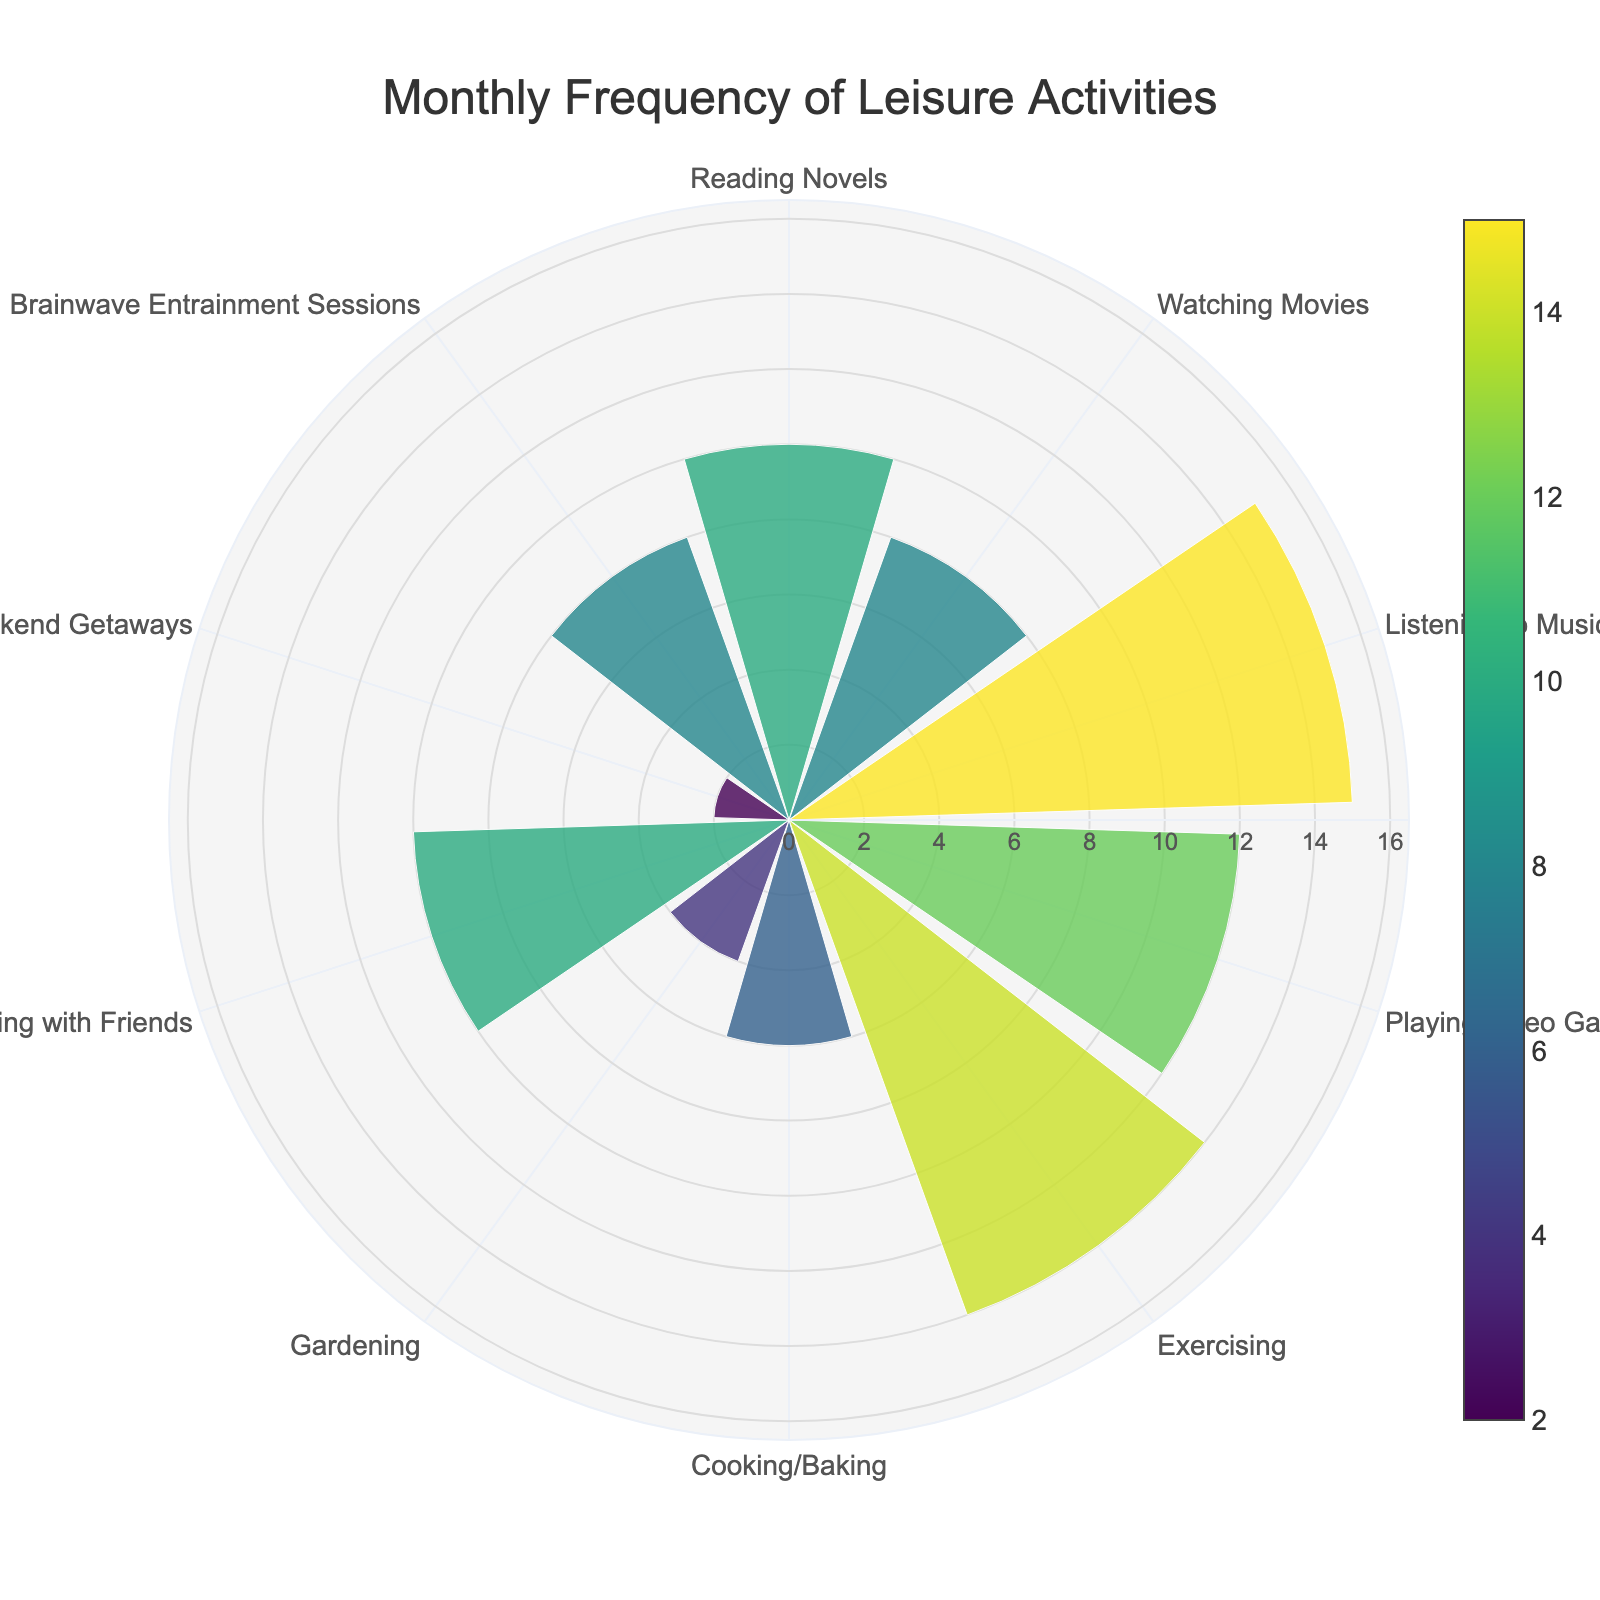What is the title of the chart? The title of the chart is usually displayed prominently at the top. By looking at the top center area of the figure, we can read the title "Monthly Frequency of Leisure Activities".
Answer: Monthly Frequency of Leisure Activities Which leisure activity has the highest frequency? To identify the activity with the highest frequency, look at the radial bars and see which one extends the furthest from the center. Listening to Music has the highest extension.
Answer: Listening to Music How many times per month do you have Brainwave Entrainment Sessions? By finding the label "Brainwave Entrainment Sessions" and looking at its corresponding bar's length and the number it corresponds to, we see it reaches up to 8 on the radial axis.
Answer: 8 What is the combined frequency of Reading Novels and Socializing with Friends in a month? To find the total, look at the bars corresponding to Reading Novels and Socializing with Friends. Reading Novels is at 10 and Socializing with Friends is also at 10. Add these together.
Answer: 20 How does Watching Movies compare to Playing Video Games in terms of frequency? Locate the bars for "Watching Movies" and "Playing Video Games". Watching Movies has a frequency of 8, while Playing Video Games has a frequency of 12, making video games more frequent.
Answer: Playing Video Games is more frequent by 4 times Which activity has the least frequency, and how many times per month is it done? Look for the bar with the smallest extension from the center. This bar corresponds to Traveling/Weekend Getaways, which is done 2 times per month.
Answer: Traveling/Weekend Getaways, 2 What is the average monthly frequency of Exercising and Cooking/Baking combined? Find the bars for Exercising (14) and Cooking/Baking (6), sum them to get 20, and then divide by 2 to find the average.
Answer: 10 What is the difference in frequency between Gardening and Socializing with Friends? Locate the lengths of the bars for Gardening (4) and Socializing with Friends (10). Subtract Gardening's frequency from Socializing with Friends' frequency.
Answer: 6 How many activities are performed more than 10 times a month? Identify all the bars taller than the 10-mark on the radial axis. Activities are Listening to Music (15), Playing Video Games (12), Exercising (14).
Answer: 3 If you were to increase the frequency of Traveling/Weekend Getaways by 4 times, how would it compare to the frequency of Watching Movies? The initial frequency of Traveling/Weekend Getaways is 2. Increasing it by 4 times gives 8, which matches the frequency of Watching Movies (8).
Answer: It would be equal 